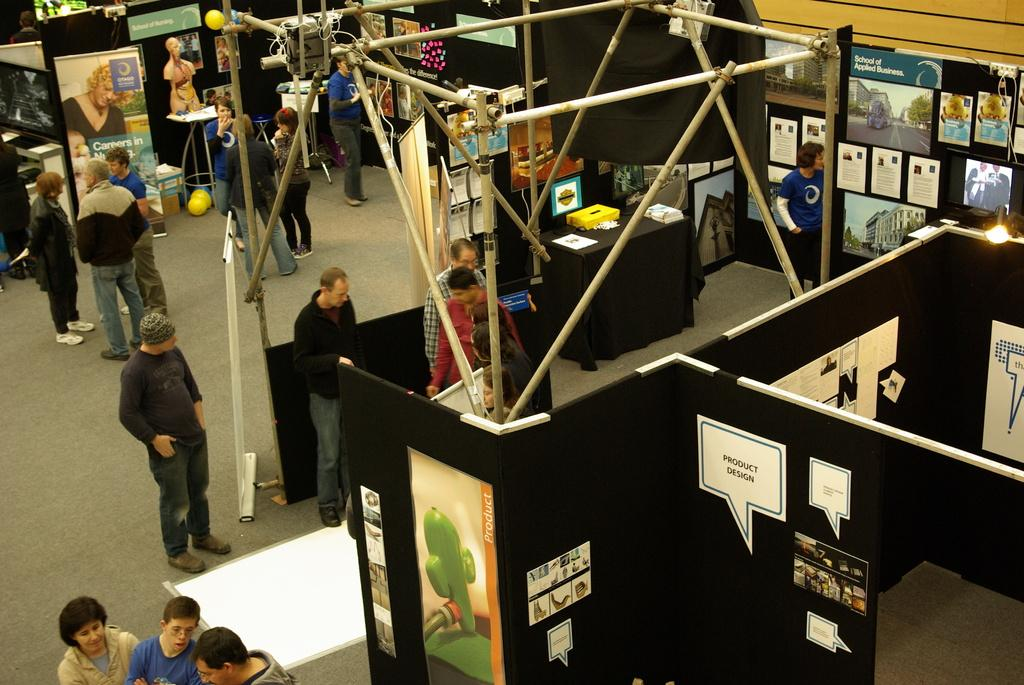What can be seen in the image involving people? There are people standing in the image. What surface are the people standing on? The people are standing on a floor. What type of structures are present in the image? There are stalls in the image. What is displayed on the stalls? There are posters on the stalls. What objects can be seen in the middle of the image? There are poles in the middle of the image. Can you see a cap on the ship in the image? There is no ship or cap present in the image. Is there a cow grazing near the poles in the image? There is no cow present in the image. 